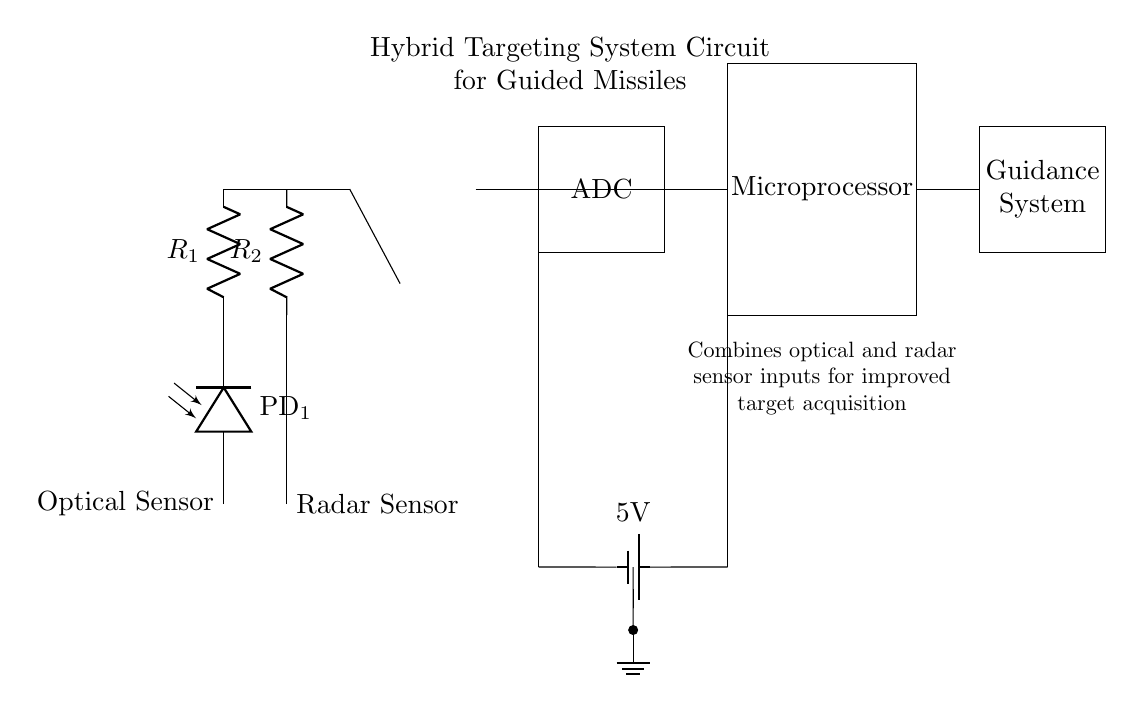What are the two types of sensors used in this circuit? The circuit utilizes an optical sensor and a radar sensor, which are clearly labeled in the diagram. The optical sensor is represented by a photodiode, and the radar sensor is indicated by an antenna symbol.
Answer: Optical sensor and radar sensor What is the role of the operational amplifier in this circuit? The operational amplifier, depicted in the circuit, is typically used to amplify signals from the optical and radar sensors, allowing for better processing of the signals by the subsequent components.
Answer: Signal amplification What is the function of the ADC in the circuit? The Analog-to-Digital Converter (ADC) is responsible for converting the analog voltage signals from the operational amplifier into digital signals that can be processed by the microprocessor. This conversion is crucial for any digital processing of sensor data.
Answer: Signal conversion How is power supplied to the circuit? Power is supplied by a battery, which is indicated by the battery symbol labeled 5V. The circuit shows connections from the battery to various components, indicating a direct voltage source for operation.
Answer: 5V battery What connects the microprocessor to the ADC? The microprocessor receives signals from the ADC through a direct wire connection as illustrated in the circuit. This connection allows the microprocessor to process the digital signals produced by the ADC.
Answer: Direct wire connection What is the purpose of combining the sensor inputs in this hybrid circuit? The hybrid circuit combines inputs from both optical and radar sensors to enhance target acquisition capabilities, improving the accuracy and reliability of guidance for the missile system. This combination allows the system to leverage the advantages of both sensor types.
Answer: Improved target acquisition 